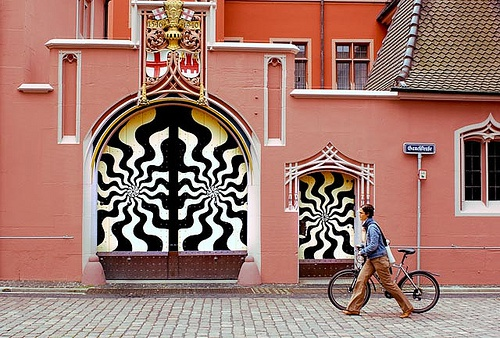Describe the objects in this image and their specific colors. I can see bicycle in salmon, black, brown, maroon, and gray tones and people in salmon, maroon, black, and brown tones in this image. 